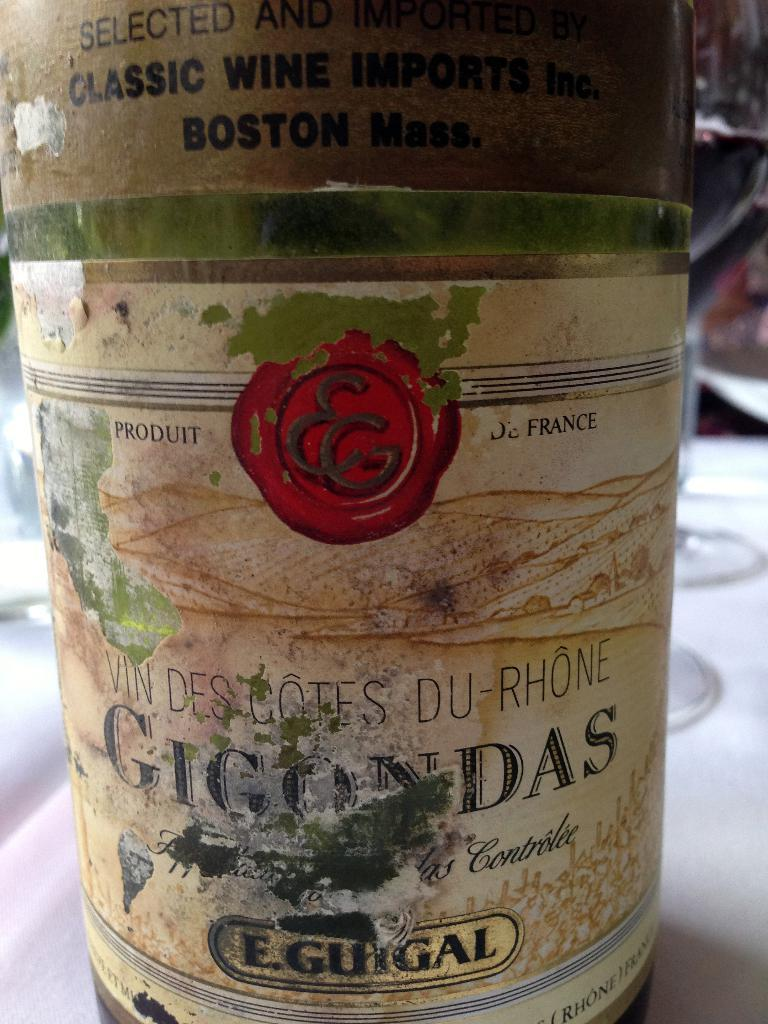<image>
Offer a succinct explanation of the picture presented. A label of an old wine bottle is shown with a sticker saying Classic wine imports on top. 